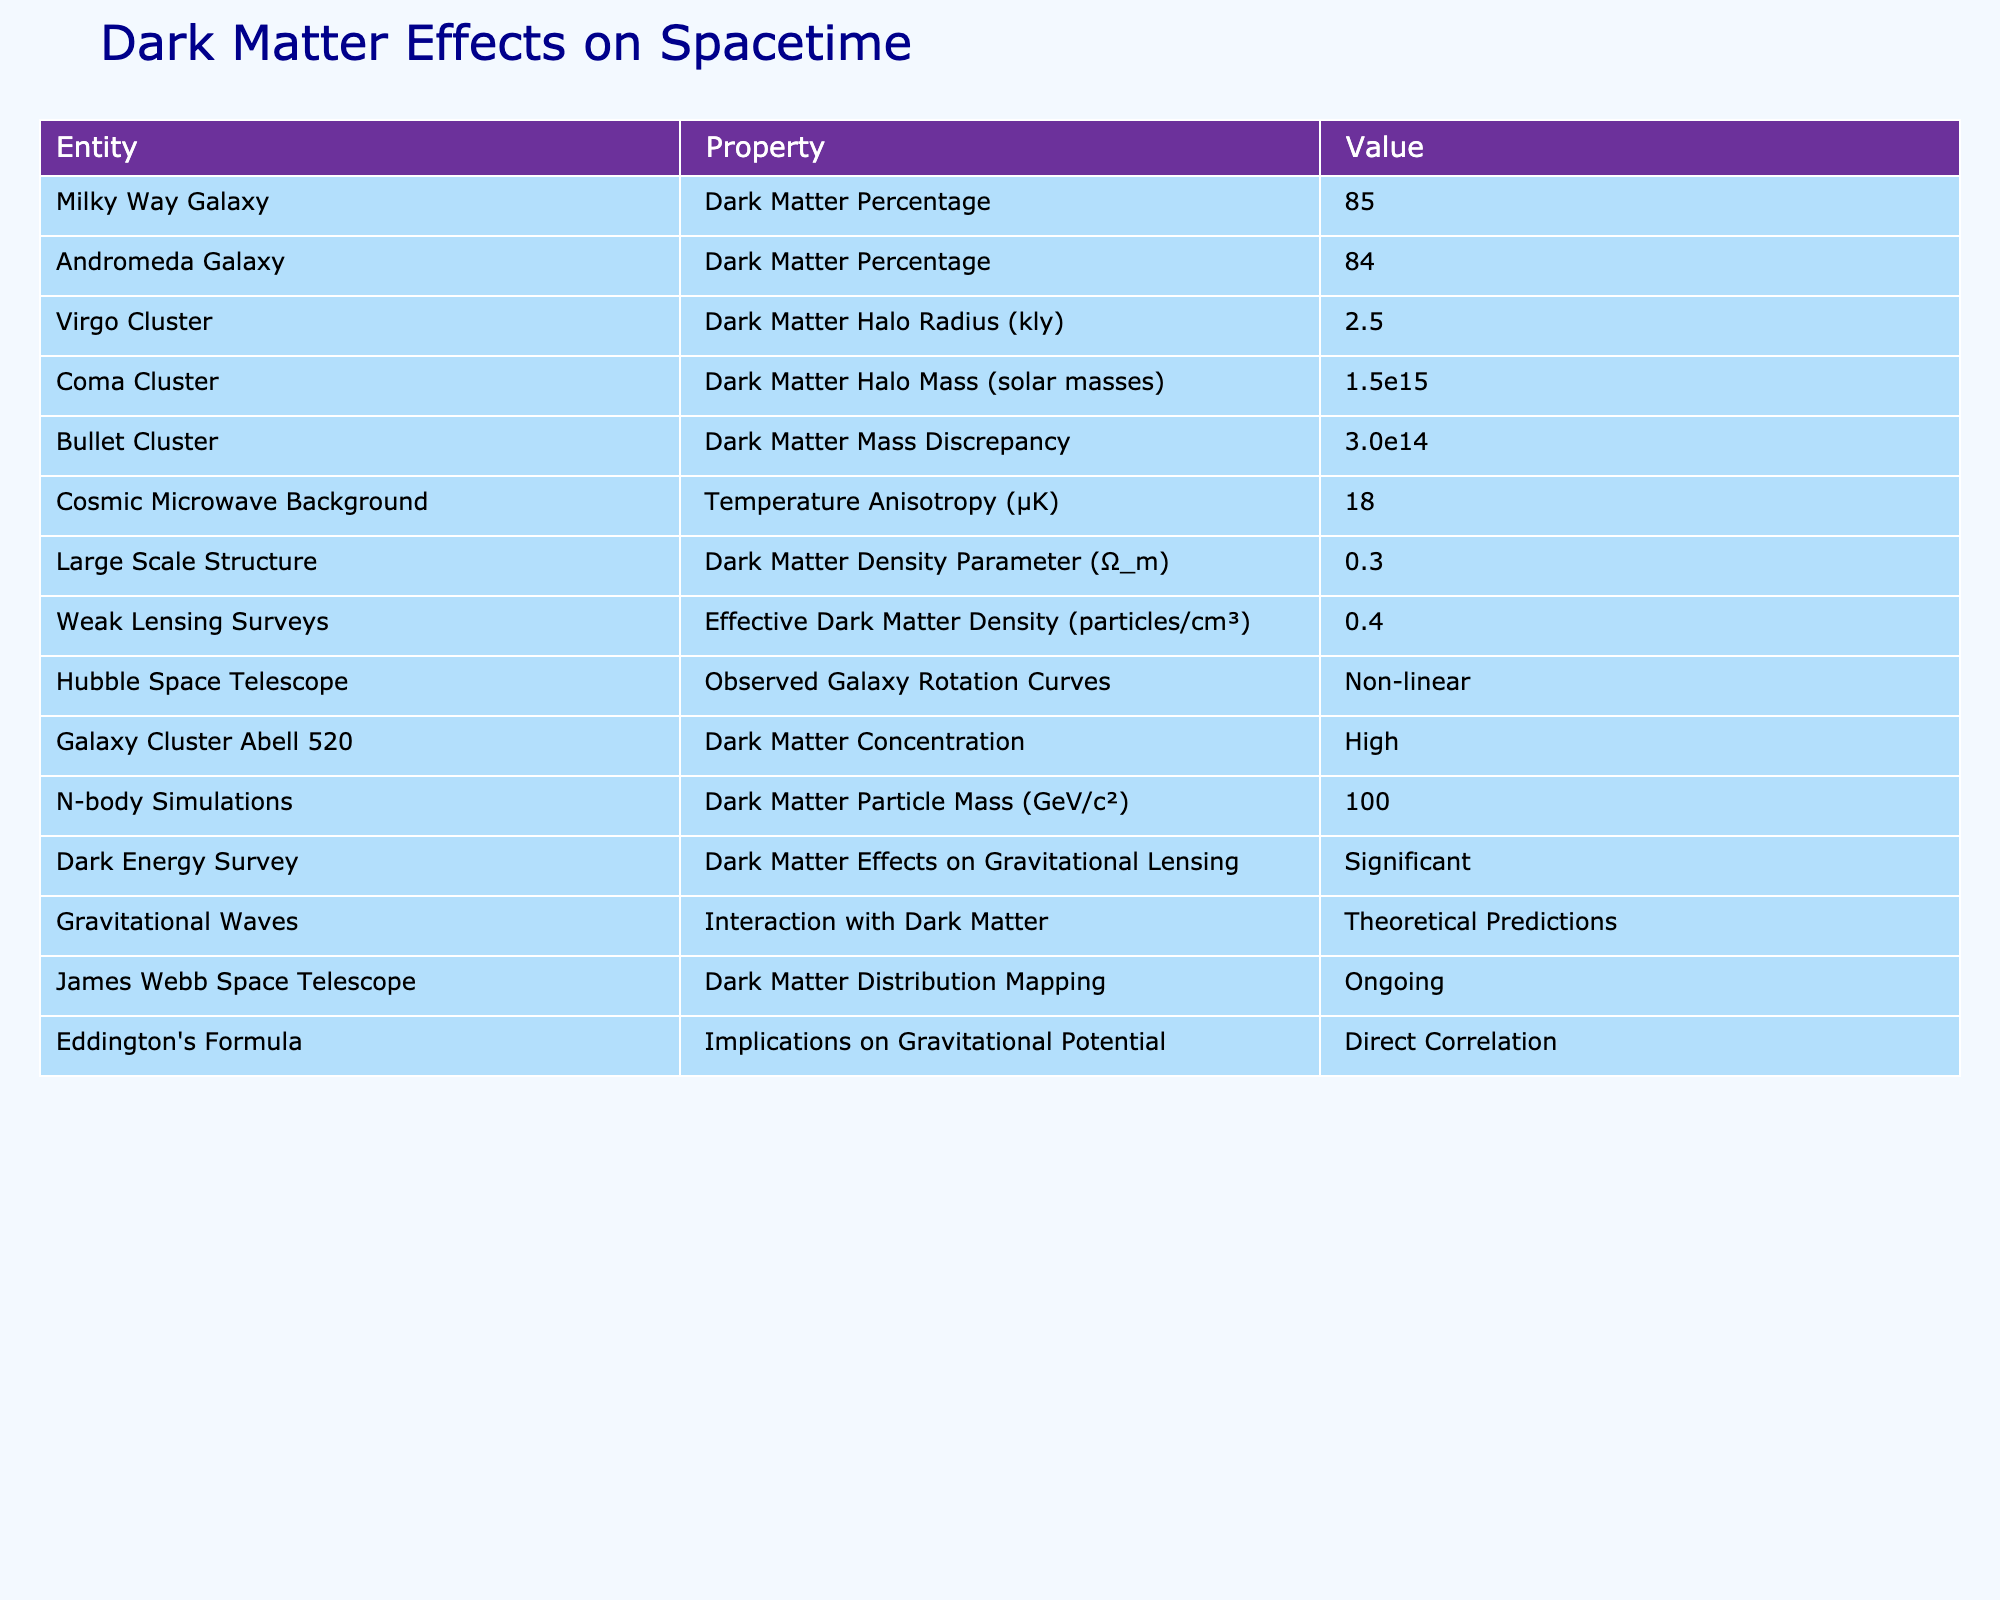What is the dark matter percentage in the Milky Way Galaxy? The table specifies that the dark matter percentage in the Milky Way Galaxy is 85.
Answer: 85 What is the dark matter halo radius of the Virgo Cluster? According to the table, the dark matter halo radius of the Virgo Cluster is 2.5 kiloparsecs.
Answer: 2.5 kly What is the dark matter halo mass of the Coma Cluster? The table indicates that the dark matter halo mass of the Coma Cluster is 1.5e15 solar masses.
Answer: 1.5e15 solar masses Is the dark matter concentration in Galaxy Cluster Abell 520 high? The table notes that the dark matter concentration in Galaxy Cluster Abell 520 is high, confirming that it is indeed high.
Answer: Yes What is the effective dark matter density reported by weak lensing surveys? The effective dark matter density reported by weak lensing surveys, as stated in the table, is 0.4 particles per cubic centimeter.
Answer: 0.4 particles/cm³ Which has a higher dark matter percentage: the Milky Way Galaxy or the Andromeda Galaxy? The Milky Way Galaxy has a dark matter percentage of 85 while the Andromeda Galaxy has 84, indicating that the Milky Way Galaxy has a higher percentage.
Answer: Milky Way Galaxy What is the discrepancy in dark matter mass for the Bullet Cluster? The table shows that the dark matter mass discrepancy for the Bullet Cluster is 3.0e14 solar masses.
Answer: 3.0e14 solar masses What is the average dark matter percentage of the Milky Way and Andromeda Galaxies? The dark matter percentage for the Milky Way is 85 and for Andromeda is 84. The average is (85 + 84)/2 = 84.5.
Answer: 84.5 What is the temperature anisotropy of the cosmic microwave background? The table states that the temperature anisotropy of the cosmic microwave background is 18 microkelvins.
Answer: 18 µK Is there ongoing mapping of dark matter distribution by the James Webb Space Telescope? The table confirms that the James Webb Space Telescope is involved in ongoing dark matter distribution mapping, making it true.
Answer: Yes What does Eddington's formula indicate about gravitational potential in relation to dark matter? The table explains that Eddington's formula has a direct correlation with gravitational potential, indicating a significant relationship.
Answer: Direct correlation How does the dark matter density parameter (Ω_m) compare with the effective dark matter density reported by weak lensing surveys? The dark matter density parameter is 0.3, and the effective dark matter density is 0.4 particles per cm³, which shows that the effective density is higher.
Answer: Effective density is higher What implications does dark matter have on gravitational lensing according to the Dark Energy Survey? The table indicates that the effects of dark matter on gravitational lensing are significant according to the Dark Energy Survey, showing a notable relationship.
Answer: Significant effects What could be inferred about the interaction of gravitational waves with dark matter based on theoretical predictions? The table mentions that the interaction with dark matter is based on theoretical predictions, indicating a speculative relationship thus far.
Answer: Theoretical predictions 